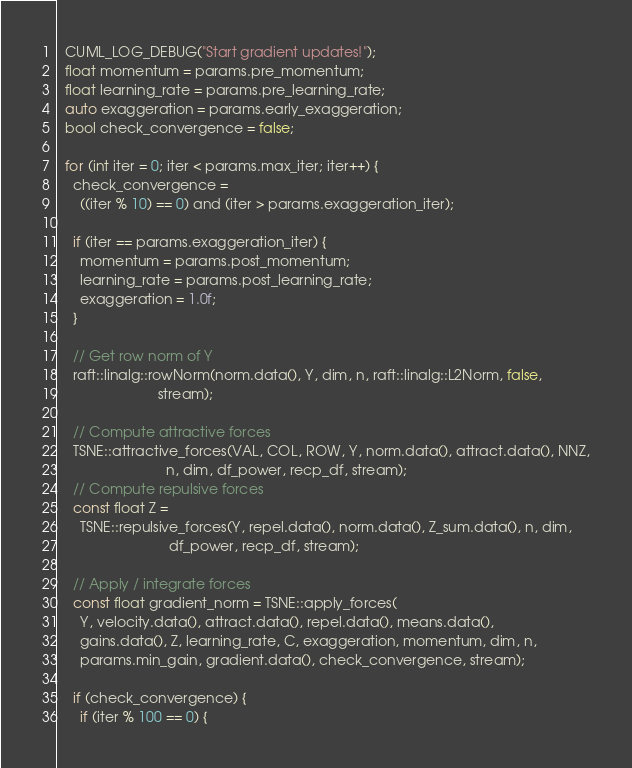Convert code to text. <code><loc_0><loc_0><loc_500><loc_500><_Cuda_>
  CUML_LOG_DEBUG("Start gradient updates!");
  float momentum = params.pre_momentum;
  float learning_rate = params.pre_learning_rate;
  auto exaggeration = params.early_exaggeration;
  bool check_convergence = false;

  for (int iter = 0; iter < params.max_iter; iter++) {
    check_convergence =
      ((iter % 10) == 0) and (iter > params.exaggeration_iter);

    if (iter == params.exaggeration_iter) {
      momentum = params.post_momentum;
      learning_rate = params.post_learning_rate;
      exaggeration = 1.0f;
    }

    // Get row norm of Y
    raft::linalg::rowNorm(norm.data(), Y, dim, n, raft::linalg::L2Norm, false,
                          stream);

    // Compute attractive forces
    TSNE::attractive_forces(VAL, COL, ROW, Y, norm.data(), attract.data(), NNZ,
                            n, dim, df_power, recp_df, stream);
    // Compute repulsive forces
    const float Z =
      TSNE::repulsive_forces(Y, repel.data(), norm.data(), Z_sum.data(), n, dim,
                             df_power, recp_df, stream);

    // Apply / integrate forces
    const float gradient_norm = TSNE::apply_forces(
      Y, velocity.data(), attract.data(), repel.data(), means.data(),
      gains.data(), Z, learning_rate, C, exaggeration, momentum, dim, n,
      params.min_gain, gradient.data(), check_convergence, stream);

    if (check_convergence) {
      if (iter % 100 == 0) {</code> 